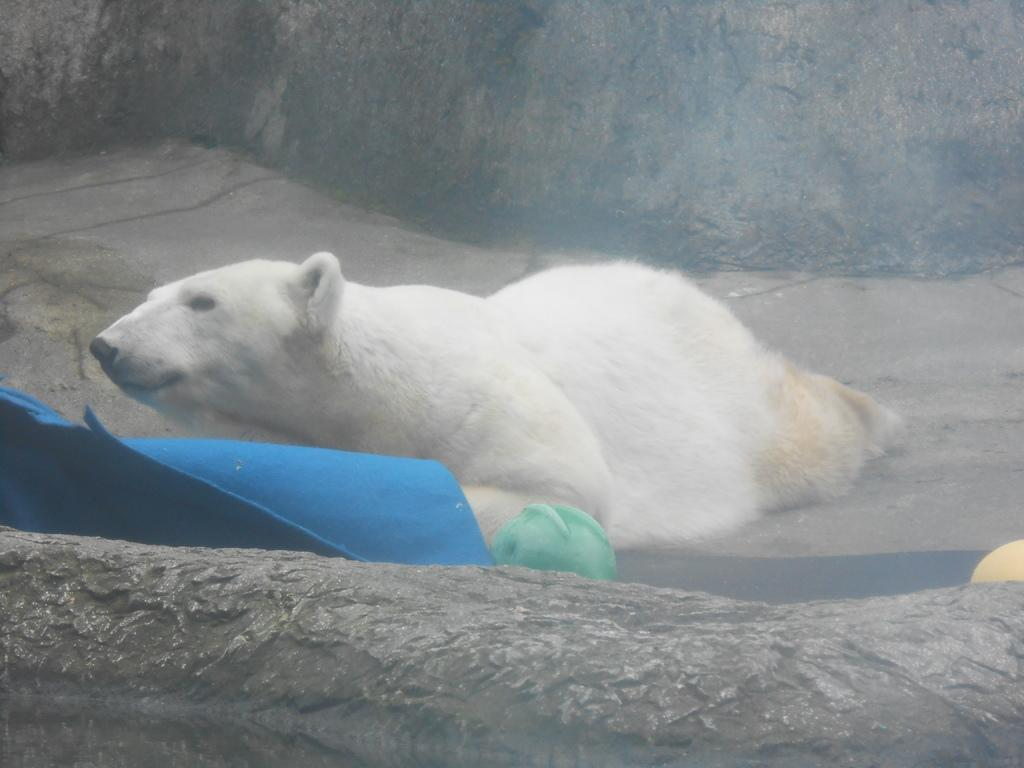What is the main subject of the image? There is a white color bear in the image. Where is the bear located in the image? The bear is in the middle of the image. What is in front of the bear? There is a blue color mat in front of the bear. What can be seen in the background of the image? There is a rock visible in the background of the image. What type of silk fabric is draped over the bear in the image? There is no silk fabric present in the image; the bear is standing on a blue color mat. 